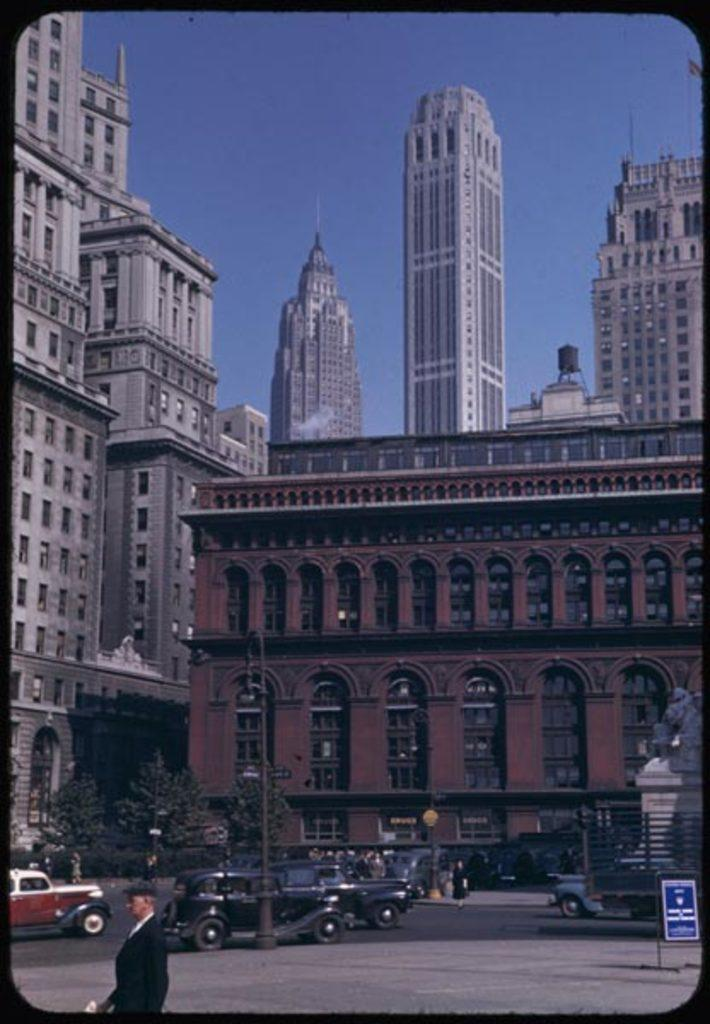What type of structures can be seen in the image? There are buildings in the image. What other natural elements are present in the image? There are trees in the image. What are the vertical structures in the image used for? There are poles in the image, which are likely used for support or signage. What type of transportation is visible in the image? There are vehicles in the image. Are there any living beings in the image? Yes, there are people in the image. What can be seen under the people and vehicles in the image? The ground is visible in the image. What is the rectangular object in the image used for? There is a board in the image, which could be used for displaying information or advertisements. What type of artwork is present in the image? There is a statue in the image. What part of the natural environment is visible in the image? The sky is visible in the image. How many cherries are hanging from the statue in the image? There are no cherries present in the image; the statue is the only object mentioned in the provided facts. What type of approval is required to climb the poles in the image? There is no mention of climbing the poles or any approval process in the provided facts. 